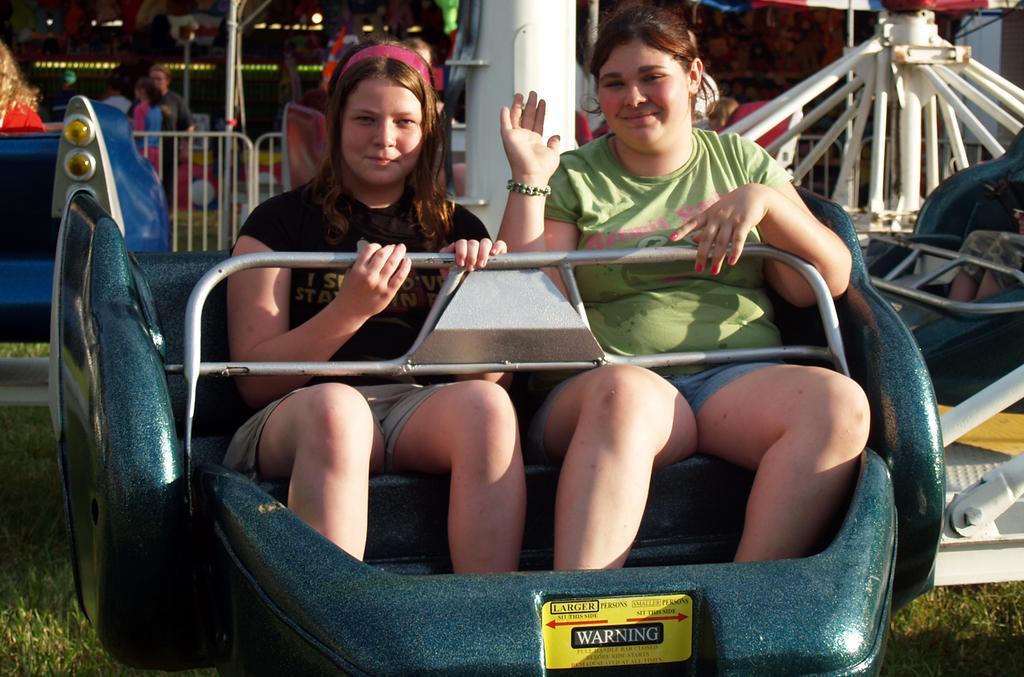Can you describe this image briefly? In this picture we can see two women are sitting in a roller coaster, at the bottom there is grass, in the background we can see barricades and some people. 